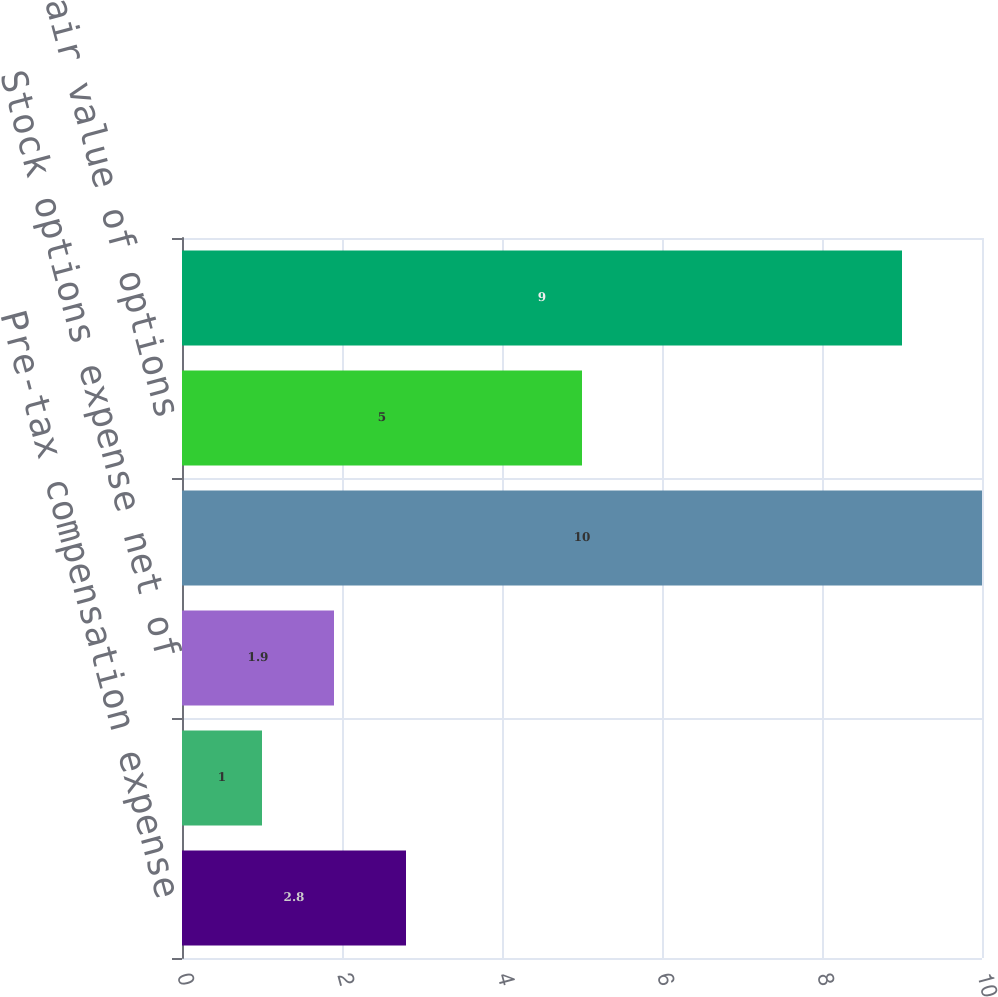Convert chart. <chart><loc_0><loc_0><loc_500><loc_500><bar_chart><fcel>Pre-tax compensation expense<fcel>Tax benefit<fcel>Stock options expense net of<fcel>Total intrinsic value of<fcel>Total fair value of options<fcel>Cash received from the<nl><fcel>2.8<fcel>1<fcel>1.9<fcel>10<fcel>5<fcel>9<nl></chart> 